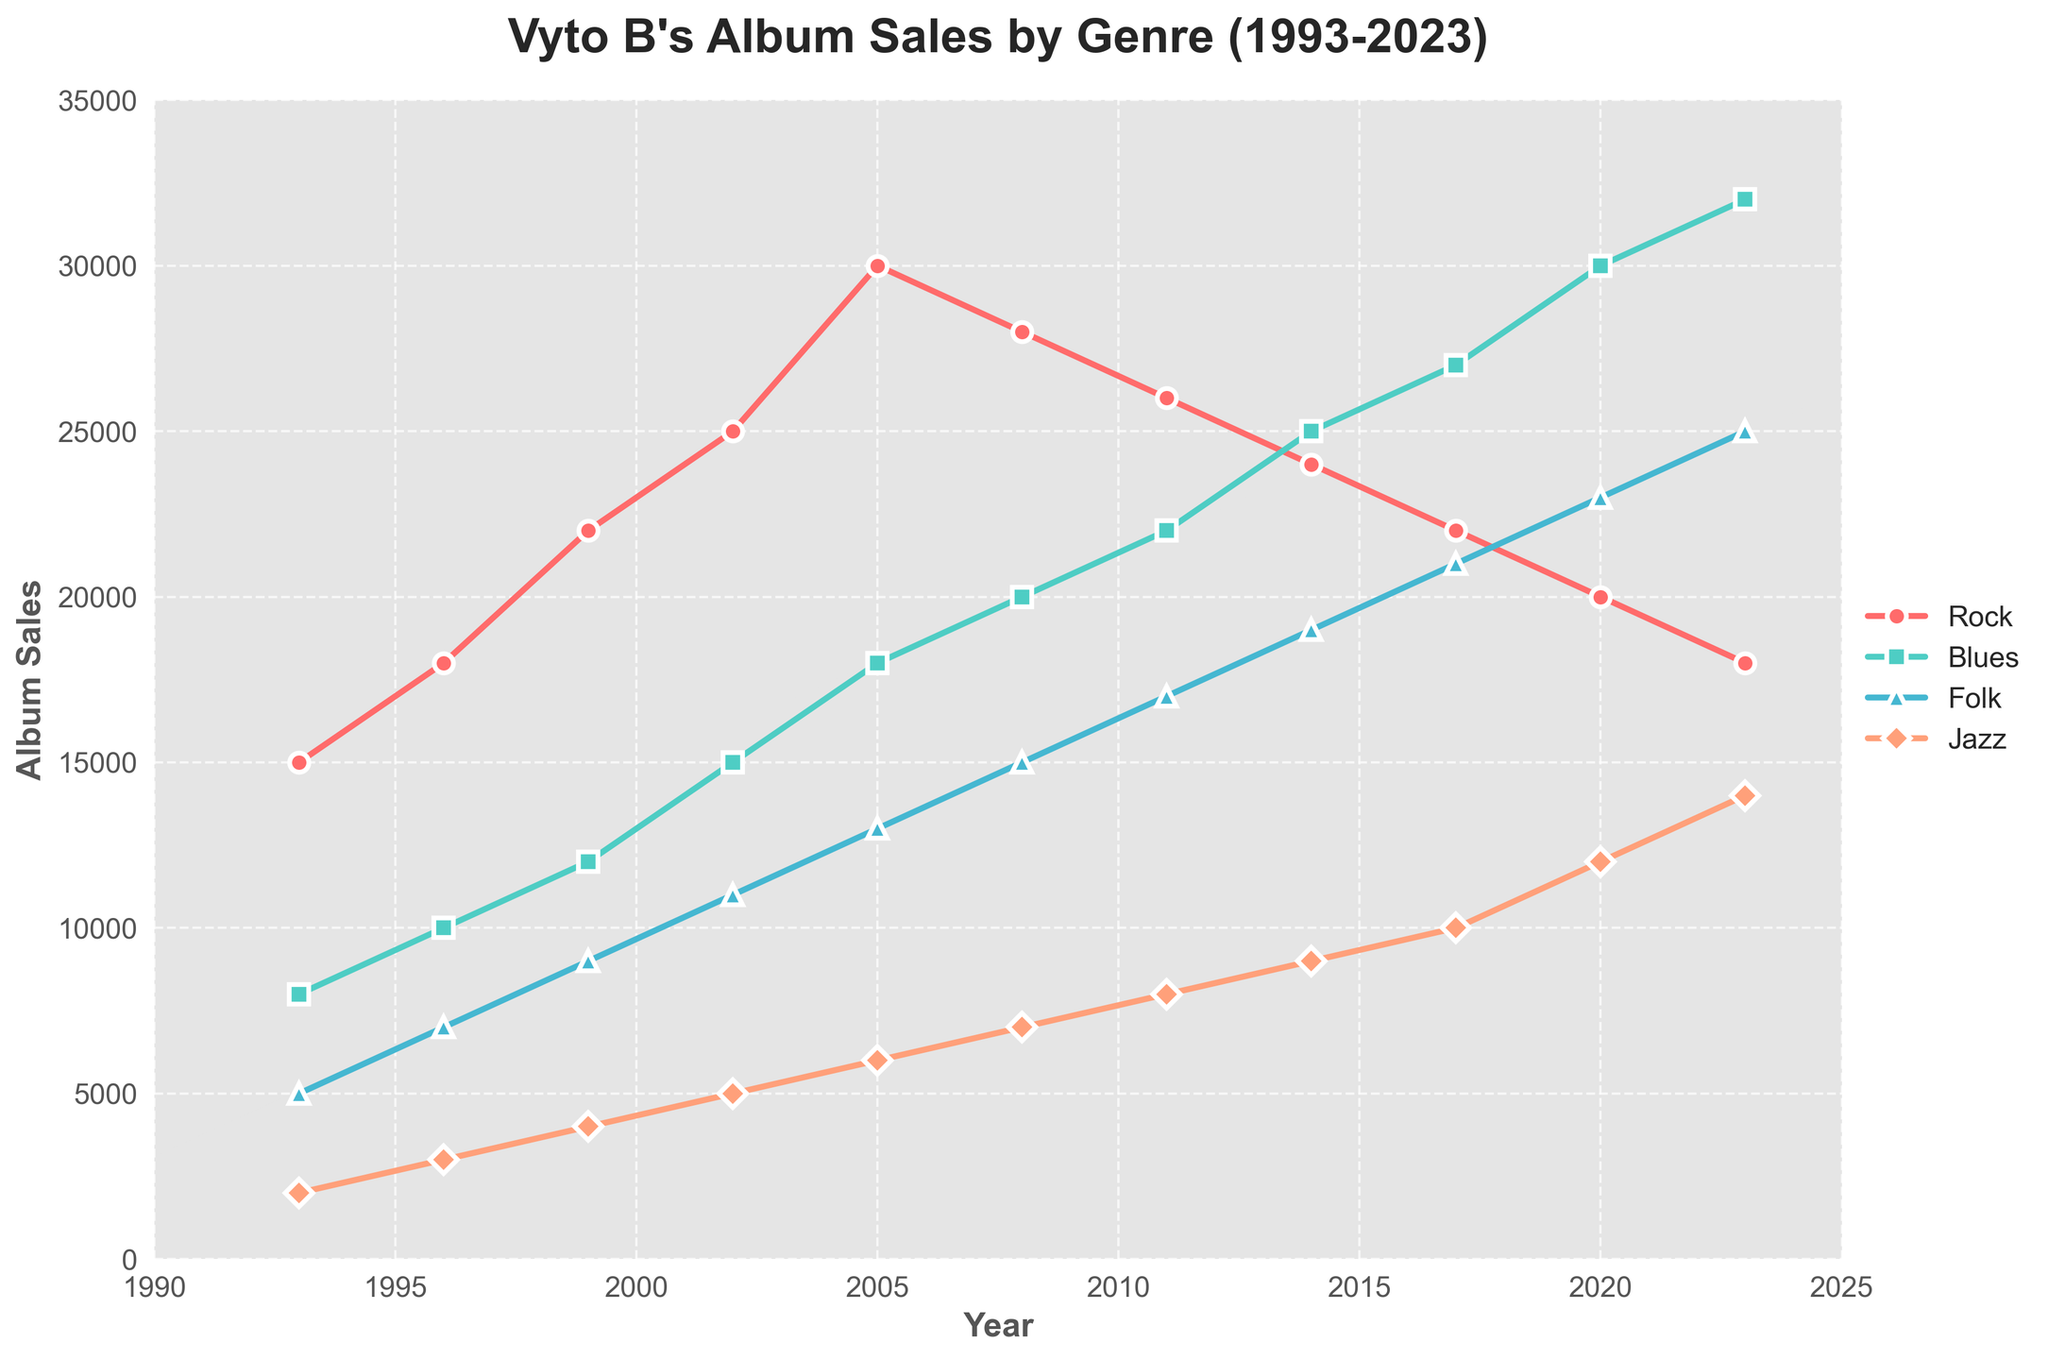Which genre had the highest album sales in 2023? Look at the endpoints of each line in the graph for 2023. The highest point corresponds to the genre with the greatest sales. The Blue genre is at the top in 2023.
Answer: Blues How many years was Rock the top-selling genre? Examine the lines and note when Rock is the top line. Rock is the highest in 1993, 1996, 1999, 2002, and 2005.
Answer: 5 In which year did Jazz overtake Folk in sales? Look for intersections where the Jazz line passes above the Folk line. This happens in 2023.
Answer: 2023 What was the difference in album sales between Blues and Rock in 2002? Find the sales numbers for both genres in 2002 and subtract them (15000 - 25000 = 10000).
Answer: 10000 Describe the trend in Folk album sales from 1993 to 2023. Observe the Folk line graph; it gradually rises from 5000 in 1993 to 25000 in 2023.
Answer: Increasing Which year had the closest sales figures for Rock and Jazz? Identify points where Rock and Jazz lines are nearest. The closest sales are in 2023 where Rock is 18000 and Jazz is 14000.
Answer: 2023 Compare the sales increase of Blues between 1993 and 2023 to Rock in the same period. Calculate the differences from start to end for both genres: Blues (32000 - 8000 = 24000) and Rock (18000 - 15000 = 3000). The increase for Blues is significantly higher than for Rock.
Answer: Blues had a higher increase What's the average album sales of Folk over the period 1993 to 2023? Sum the Folk sales for all years and divide by 11: (5000 + 7000 + 9000 + 11000 + 13000 + 15000 + 17000 + 19000 + 21000 + 23000 + 25000) / 11 = 14545.45.
Answer: 14545.45 Which genre had the most consistent increase in sales over the years? Compare the slopes of the lines; Blues shows a steady upward trend from the start to the end.
Answer: Blues 